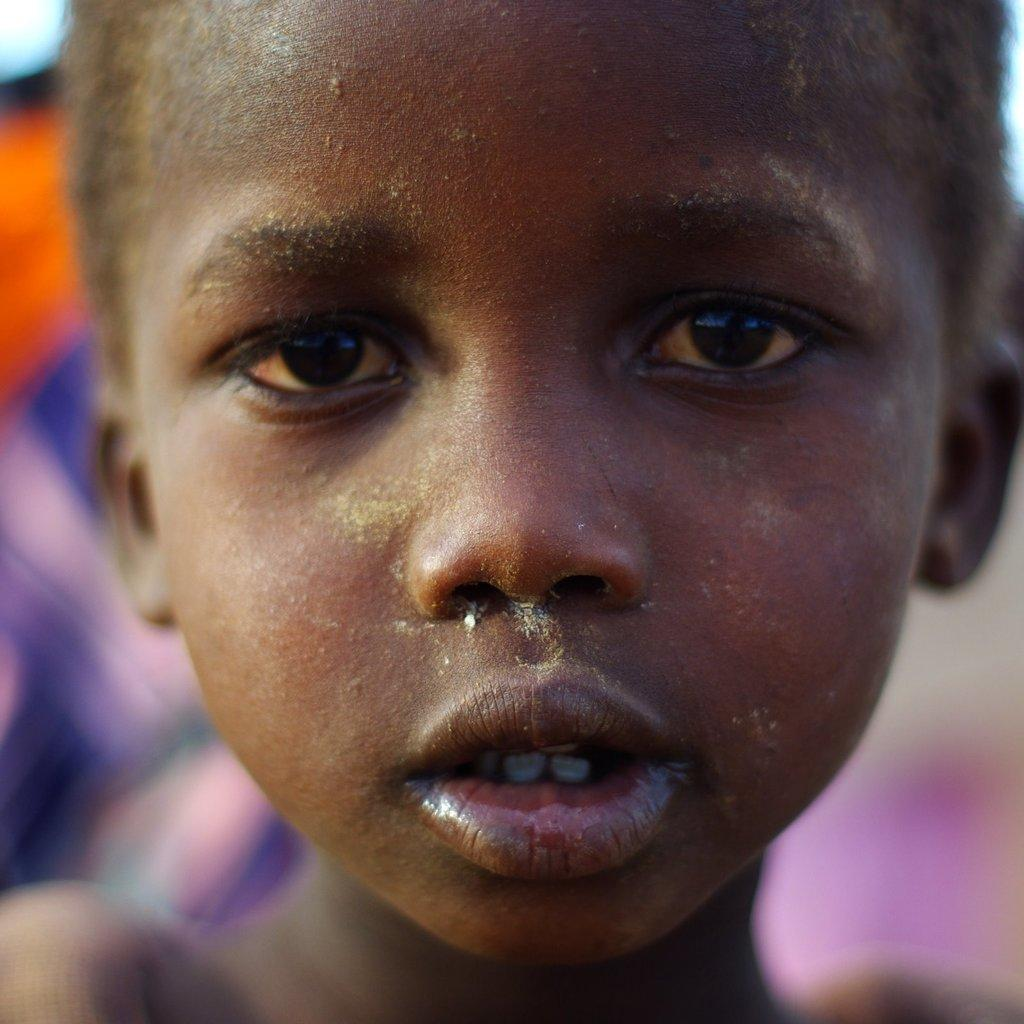What is the main subject of the image? There is a boy in the image. Can you describe the background of the image? The background of the image is blurred. How many fingers does the boy have on his right hand in the image? There is no information provided about the boy's fingers in the image, so it cannot be determined. What type of party is depicted in the image? There is no party present in the image; it only features a boy and a blurred background. 